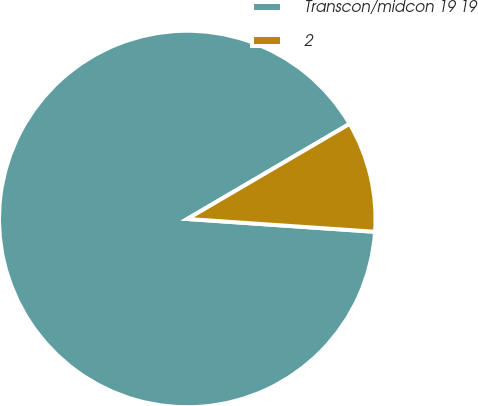Convert chart to OTSL. <chart><loc_0><loc_0><loc_500><loc_500><pie_chart><fcel>Transcon/midcon 19 19<fcel>2<nl><fcel>90.48%<fcel>9.52%<nl></chart> 